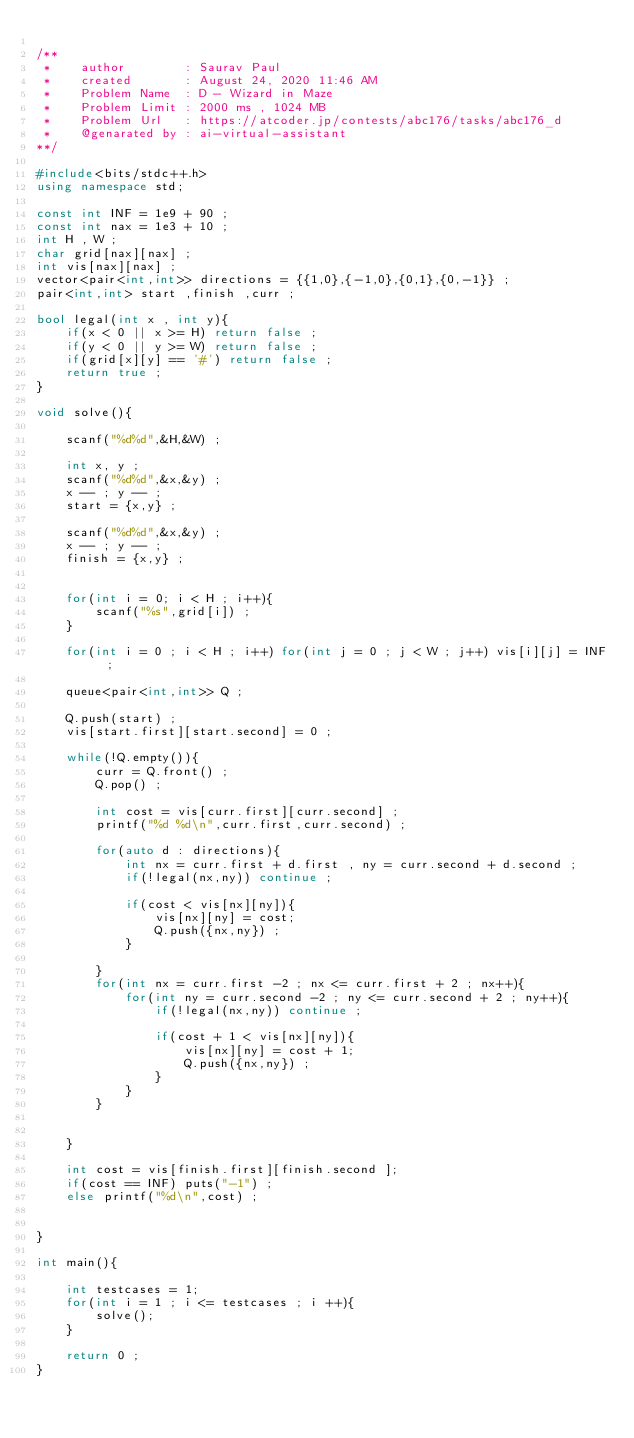<code> <loc_0><loc_0><loc_500><loc_500><_C++_>
/**
 *    author        : Saurav Paul 
 *    created       : August 24, 2020 11:46 AM
 *    Problem Name  : D - Wizard in Maze
 *    Problem Limit : 2000 ms , 1024 MB
 *    Problem Url   : https://atcoder.jp/contests/abc176/tasks/abc176_d
 *    @genarated by : ai-virtual-assistant
**/

#include<bits/stdc++.h>
using namespace std;

const int INF = 1e9 + 90 ;
const int nax = 1e3 + 10 ;
int H , W ;
char grid[nax][nax] ;
int vis[nax][nax] ;
vector<pair<int,int>> directions = {{1,0},{-1,0},{0,1},{0,-1}} ;
pair<int,int> start ,finish ,curr ;

bool legal(int x , int y){
    if(x < 0 || x >= H) return false ;
    if(y < 0 || y >= W) return false ;
    if(grid[x][y] == '#') return false ;
    return true ;
}

void solve(){

    scanf("%d%d",&H,&W) ;

    int x, y ;
    scanf("%d%d",&x,&y) ;
    x -- ; y -- ;
    start = {x,y} ;

    scanf("%d%d",&x,&y) ;
    x -- ; y -- ;
    finish = {x,y} ;


    for(int i = 0; i < H ; i++){
        scanf("%s",grid[i]) ;
    }

    for(int i = 0 ; i < H ; i++) for(int j = 0 ; j < W ; j++) vis[i][j] = INF ;

    queue<pair<int,int>> Q ;

    Q.push(start) ;
    vis[start.first][start.second] = 0 ;

    while(!Q.empty()){
        curr = Q.front() ;
        Q.pop() ;

        int cost = vis[curr.first][curr.second] ;
        printf("%d %d\n",curr.first,curr.second) ;

        for(auto d : directions){
            int nx = curr.first + d.first , ny = curr.second + d.second ;
            if(!legal(nx,ny)) continue ;

            if(cost < vis[nx][ny]){
                vis[nx][ny] = cost;
                Q.push({nx,ny}) ;
            }

        }
        for(int nx = curr.first -2 ; nx <= curr.first + 2 ; nx++){
            for(int ny = curr.second -2 ; ny <= curr.second + 2 ; ny++){
                if(!legal(nx,ny)) continue ;

                if(cost + 1 < vis[nx][ny]){
                    vis[nx][ny] = cost + 1;
                    Q.push({nx,ny}) ;
                }
            }
        }


    }

    int cost = vis[finish.first][finish.second ];
    if(cost == INF) puts("-1") ;
    else printf("%d\n",cost) ;
    

}

int main(){

    int testcases = 1;
    for(int i = 1 ; i <= testcases ; i ++){
        solve();
    }

    return 0 ;
}
</code> 